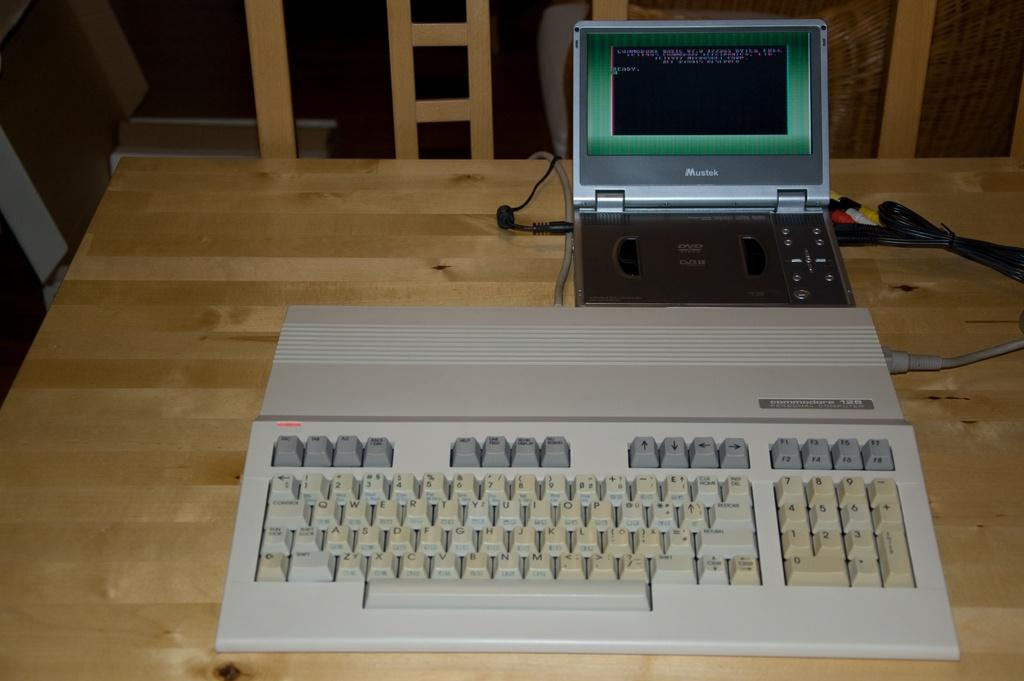<image>
Present a compact description of the photo's key features. A white keyboard is in front of a Mustek monitor. 